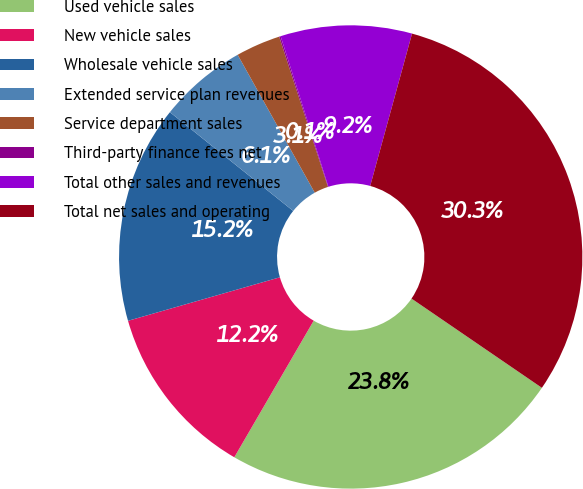<chart> <loc_0><loc_0><loc_500><loc_500><pie_chart><fcel>Used vehicle sales<fcel>New vehicle sales<fcel>Wholesale vehicle sales<fcel>Extended service plan revenues<fcel>Service department sales<fcel>Third-party finance fees net<fcel>Total other sales and revenues<fcel>Total net sales and operating<nl><fcel>23.83%<fcel>12.18%<fcel>15.19%<fcel>6.14%<fcel>3.12%<fcel>0.1%<fcel>9.16%<fcel>30.29%<nl></chart> 